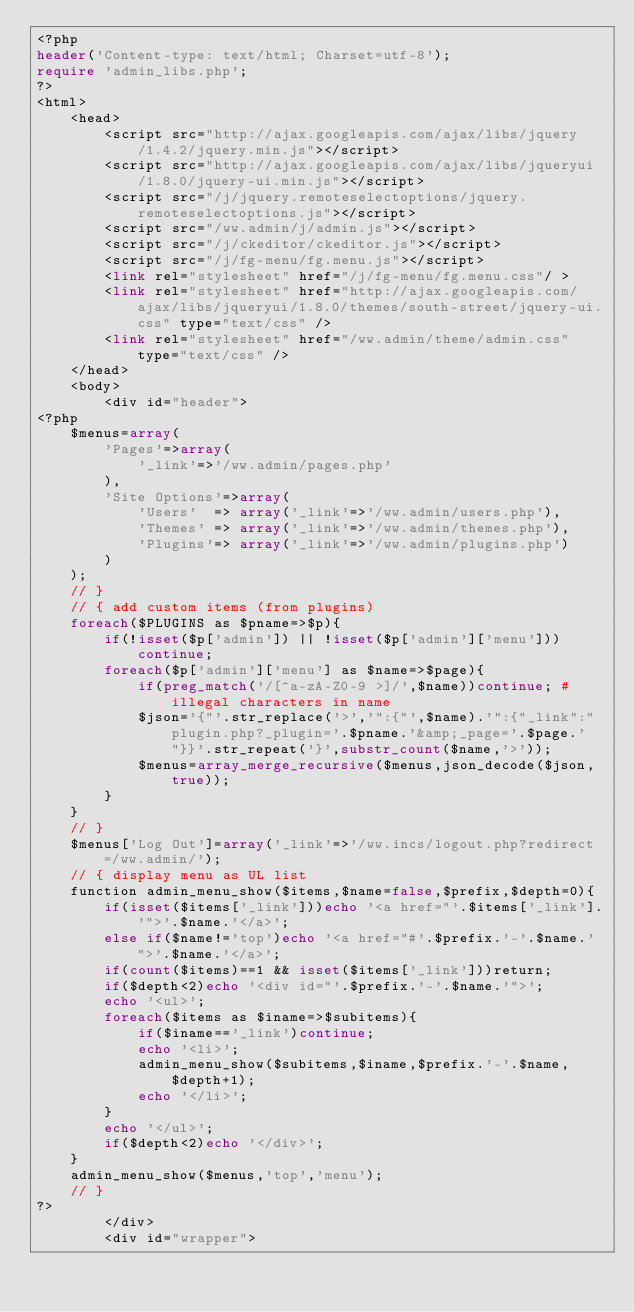Convert code to text. <code><loc_0><loc_0><loc_500><loc_500><_PHP_><?php
header('Content-type: text/html; Charset=utf-8');
require 'admin_libs.php';
?>
<html>
	<head>
		<script src="http://ajax.googleapis.com/ajax/libs/jquery/1.4.2/jquery.min.js"></script>
		<script src="http://ajax.googleapis.com/ajax/libs/jqueryui/1.8.0/jquery-ui.min.js"></script>
		<script src="/j/jquery.remoteselectoptions/jquery.remoteselectoptions.js"></script>
		<script src="/ww.admin/j/admin.js"></script>
		<script src="/j/ckeditor/ckeditor.js"></script>
		<script src="/j/fg-menu/fg.menu.js"></script>
		<link rel="stylesheet" href="/j/fg-menu/fg.menu.css"/ >
		<link rel="stylesheet" href="http://ajax.googleapis.com/ajax/libs/jqueryui/1.8.0/themes/south-street/jquery-ui.css" type="text/css" />
		<link rel="stylesheet" href="/ww.admin/theme/admin.css" type="text/css" />
	</head>
	<body>
		<div id="header"> 
<?php
	$menus=array(
		'Pages'=>array(
			'_link'=>'/ww.admin/pages.php'
		),
		'Site Options'=>array(
			'Users'  => array('_link'=>'/ww.admin/users.php'),
			'Themes' => array('_link'=>'/ww.admin/themes.php'),
			'Plugins'=> array('_link'=>'/ww.admin/plugins.php')
		)
	);
	// }
	// { add custom items (from plugins)
	foreach($PLUGINS as $pname=>$p){
		if(!isset($p['admin']) || !isset($p['admin']['menu']))continue;
		foreach($p['admin']['menu'] as $name=>$page){
			if(preg_match('/[^a-zA-Z0-9 >]/',$name))continue; # illegal characters in name
			$json='{"'.str_replace('>','":{"',$name).'":{"_link":"plugin.php?_plugin='.$pname.'&amp;_page='.$page.'"}}'.str_repeat('}',substr_count($name,'>'));
			$menus=array_merge_recursive($menus,json_decode($json,true));
		}
	}
	// }
	$menus['Log Out']=array('_link'=>'/ww.incs/logout.php?redirect=/ww.admin/');
	// { display menu as UL list
	function admin_menu_show($items,$name=false,$prefix,$depth=0){
		if(isset($items['_link']))echo '<a href="'.$items['_link'].'">'.$name.'</a>';
		else if($name!='top')echo '<a href="#'.$prefix.'-'.$name.'">'.$name.'</a>';
		if(count($items)==1 && isset($items['_link']))return;
		if($depth<2)echo '<div id="'.$prefix.'-'.$name.'">';
		echo '<ul>';
		foreach($items as $iname=>$subitems){
			if($iname=='_link')continue;
			echo '<li>';
			admin_menu_show($subitems,$iname,$prefix.'-'.$name,$depth+1);
			echo '</li>';
		}
		echo '</ul>';
		if($depth<2)echo '</div>';
	}
	admin_menu_show($menus,'top','menu');
	// }
?>
		</div>
		<div id="wrapper">
</code> 